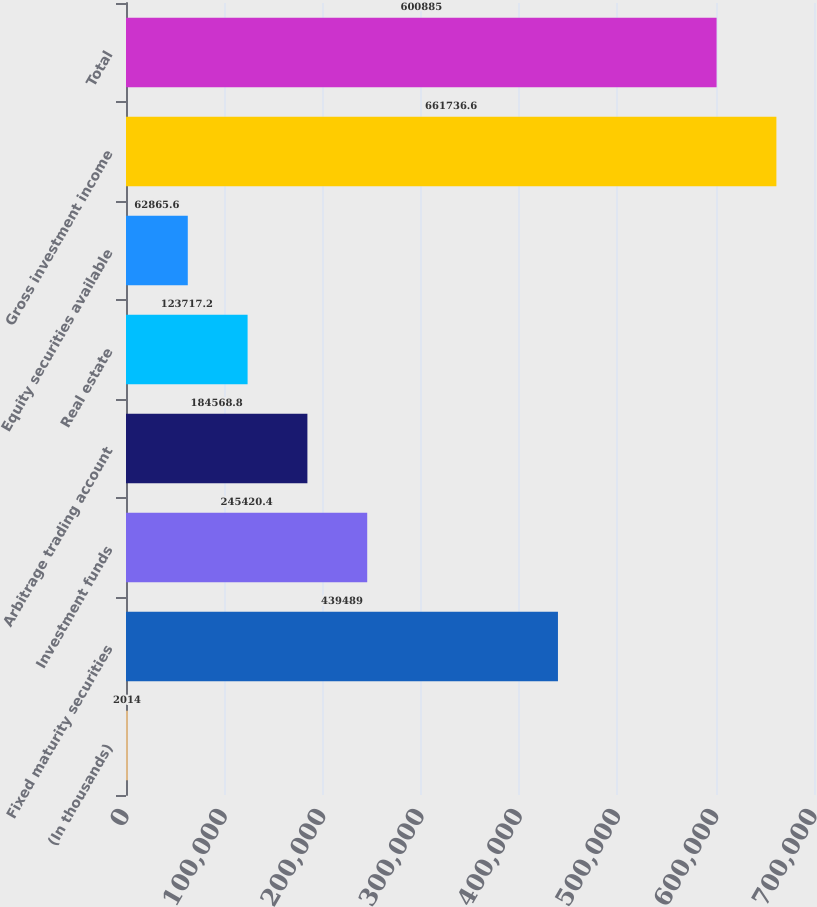Convert chart to OTSL. <chart><loc_0><loc_0><loc_500><loc_500><bar_chart><fcel>(In thousands)<fcel>Fixed maturity securities<fcel>Investment funds<fcel>Arbitrage trading account<fcel>Real estate<fcel>Equity securities available<fcel>Gross investment income<fcel>Total<nl><fcel>2014<fcel>439489<fcel>245420<fcel>184569<fcel>123717<fcel>62865.6<fcel>661737<fcel>600885<nl></chart> 